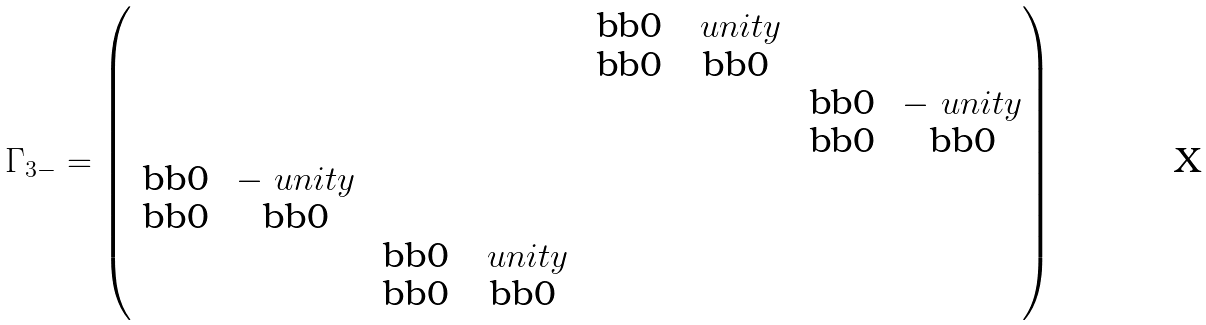Convert formula to latex. <formula><loc_0><loc_0><loc_500><loc_500>\Gamma _ { 3 - } = \begin{pmatrix} & & & & $ \text  bb{0} $ & \ u n i t y & & \\ & & & & $ \text  bb{0} $ & $ \text  bb{0} $ & & \\ & & & & & & $ \text  bb{0} $ & - \ u n i t y \\ & & & & & & $ \text  bb{0} $ & $ \text  bb{0} $ \\ $ \text  bb{0} $ & - \ u n i t y & & & & & & \\ $ \text  bb{0} $ & $ \text  bb{0} $ & & & & & & \\ & & $ \text  bb{0} $ & \ u n i t y & & & & \\ & & $ \text  bb{0} $ & $ \text  bb{0} $ & & & \end{pmatrix}</formula> 